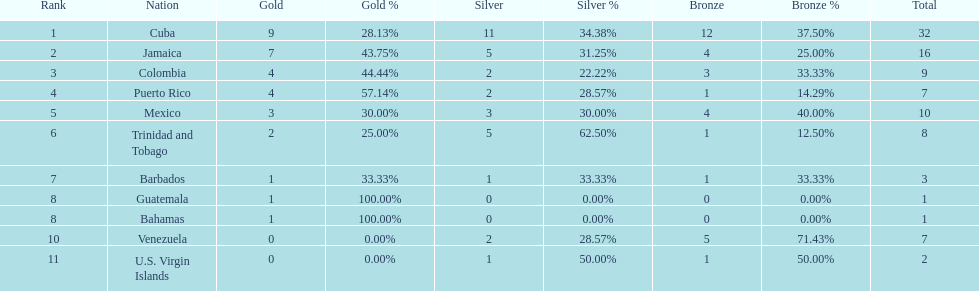Largest medal differential between countries 31. 